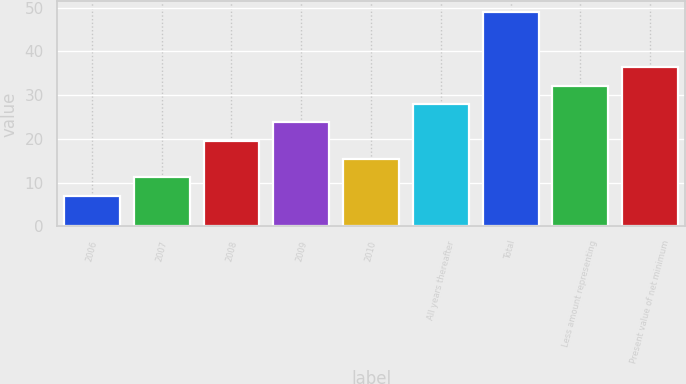Convert chart to OTSL. <chart><loc_0><loc_0><loc_500><loc_500><bar_chart><fcel>2006<fcel>2007<fcel>2008<fcel>2009<fcel>2010<fcel>All years thereafter<fcel>Total<fcel>Less amount representing<fcel>Present value of net minimum<nl><fcel>7<fcel>11.2<fcel>19.6<fcel>23.8<fcel>15.4<fcel>28<fcel>49<fcel>32.2<fcel>36.4<nl></chart> 